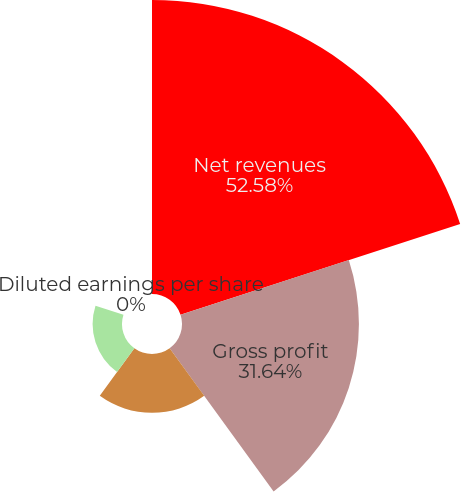Convert chart. <chart><loc_0><loc_0><loc_500><loc_500><pie_chart><fcel>Net revenues<fcel>Gross profit<fcel>Net income/(loss)<fcel>Basic earnings per share<fcel>Diluted earnings per share<nl><fcel>52.58%<fcel>31.64%<fcel>10.52%<fcel>5.26%<fcel>0.0%<nl></chart> 